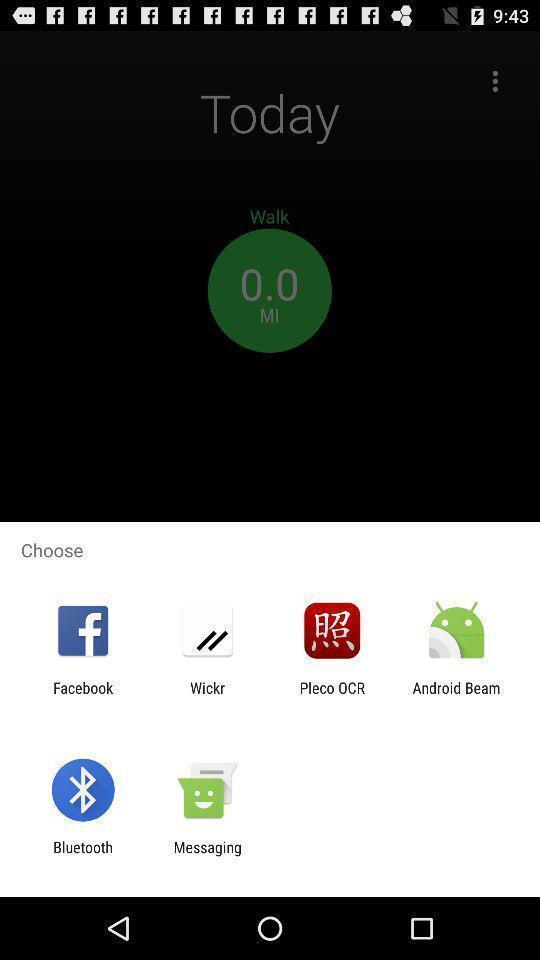Describe the content in this image. Screen showing various applications to choose. 